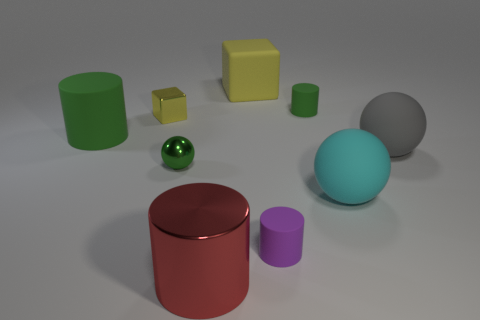How many things are either tiny objects that are behind the cyan rubber ball or cyan shiny cubes?
Offer a terse response. 3. What shape is the thing that is both left of the small purple matte thing and in front of the large cyan matte object?
Keep it short and to the point. Cylinder. What number of objects are spheres that are on the left side of the gray sphere or green rubber things right of the big yellow matte block?
Give a very brief answer. 3. What number of other objects are the same size as the yellow metal thing?
Provide a succinct answer. 3. There is a large matte thing to the left of the big red metallic object; does it have the same color as the shiny ball?
Offer a very short reply. Yes. What is the size of the cylinder that is both behind the tiny green shiny sphere and to the right of the small yellow cube?
Your answer should be compact. Small. How many big things are either matte spheres or shiny blocks?
Your answer should be compact. 2. What is the shape of the green matte thing that is right of the small purple object?
Ensure brevity in your answer.  Cylinder. What number of tiny gray balls are there?
Ensure brevity in your answer.  0. Is the large cyan sphere made of the same material as the large gray object?
Ensure brevity in your answer.  Yes. 